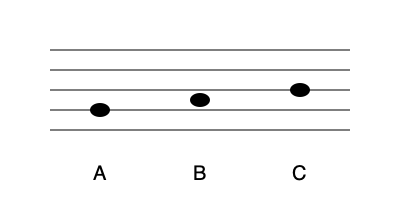Hey there, music enthusiast! Let's have some fun with this simplified sheet music. Can you identify which note is the highest pitch? Don't worry, we'll keep it light and breezy! Alright, let's break this down with a smile:

1. In sheet music, the higher a note is on the staff (the five horizontal lines), the higher its pitch.

2. We have three notes here, labeled A, B, and C.

3. Note A is sitting on the second line from the bottom. That's pretty low!

4. Note B is hanging out between the second and third lines. It's moved up a bit, like it's trying to get a better view.

5. Note C is perched right on the third line from the bottom. Look at it go!

6. If we compare their positions, we can see that C is the highest on the staff.

7. Therefore, C is our high-flying note with the highest pitch!

Remember, in music, as in life, sometimes you've got to reach for those high notes!
Answer: C 